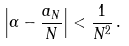<formula> <loc_0><loc_0><loc_500><loc_500>\left | \alpha - \frac { a _ { N } } { N } \right | < \frac { 1 } { N ^ { 2 } } \, .</formula> 